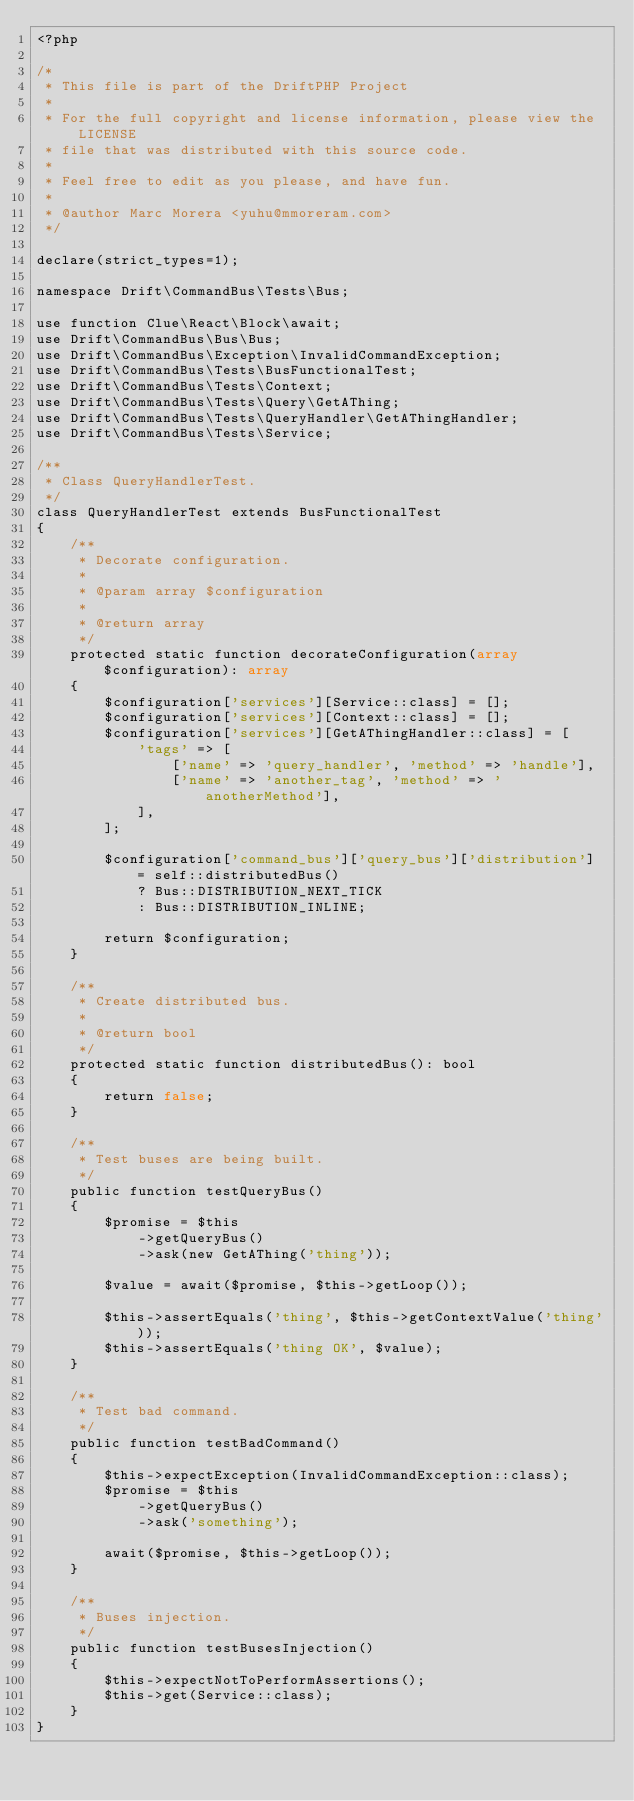Convert code to text. <code><loc_0><loc_0><loc_500><loc_500><_PHP_><?php

/*
 * This file is part of the DriftPHP Project
 *
 * For the full copyright and license information, please view the LICENSE
 * file that was distributed with this source code.
 *
 * Feel free to edit as you please, and have fun.
 *
 * @author Marc Morera <yuhu@mmoreram.com>
 */

declare(strict_types=1);

namespace Drift\CommandBus\Tests\Bus;

use function Clue\React\Block\await;
use Drift\CommandBus\Bus\Bus;
use Drift\CommandBus\Exception\InvalidCommandException;
use Drift\CommandBus\Tests\BusFunctionalTest;
use Drift\CommandBus\Tests\Context;
use Drift\CommandBus\Tests\Query\GetAThing;
use Drift\CommandBus\Tests\QueryHandler\GetAThingHandler;
use Drift\CommandBus\Tests\Service;

/**
 * Class QueryHandlerTest.
 */
class QueryHandlerTest extends BusFunctionalTest
{
    /**
     * Decorate configuration.
     *
     * @param array $configuration
     *
     * @return array
     */
    protected static function decorateConfiguration(array $configuration): array
    {
        $configuration['services'][Service::class] = [];
        $configuration['services'][Context::class] = [];
        $configuration['services'][GetAThingHandler::class] = [
            'tags' => [
                ['name' => 'query_handler', 'method' => 'handle'],
                ['name' => 'another_tag', 'method' => 'anotherMethod'],
            ],
        ];

        $configuration['command_bus']['query_bus']['distribution'] = self::distributedBus()
            ? Bus::DISTRIBUTION_NEXT_TICK
            : Bus::DISTRIBUTION_INLINE;

        return $configuration;
    }

    /**
     * Create distributed bus.
     *
     * @return bool
     */
    protected static function distributedBus(): bool
    {
        return false;
    }

    /**
     * Test buses are being built.
     */
    public function testQueryBus()
    {
        $promise = $this
            ->getQueryBus()
            ->ask(new GetAThing('thing'));

        $value = await($promise, $this->getLoop());

        $this->assertEquals('thing', $this->getContextValue('thing'));
        $this->assertEquals('thing OK', $value);
    }

    /**
     * Test bad command.
     */
    public function testBadCommand()
    {
        $this->expectException(InvalidCommandException::class);
        $promise = $this
            ->getQueryBus()
            ->ask('something');

        await($promise, $this->getLoop());
    }

    /**
     * Buses injection.
     */
    public function testBusesInjection()
    {
        $this->expectNotToPerformAssertions();
        $this->get(Service::class);
    }
}
</code> 